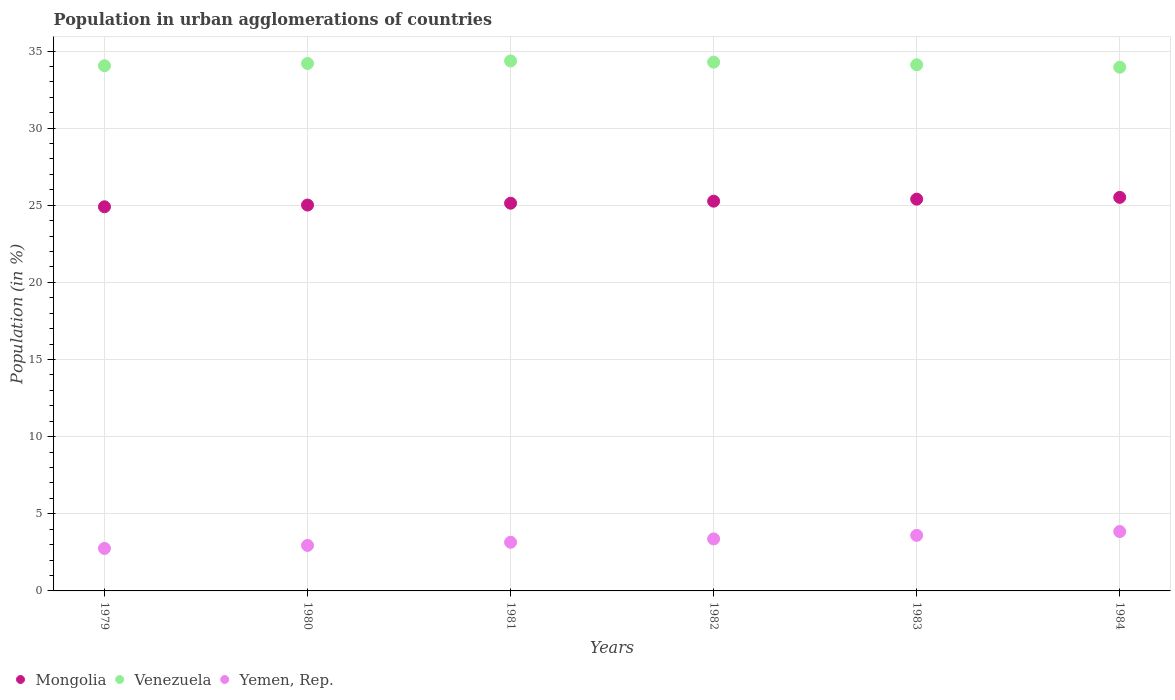What is the percentage of population in urban agglomerations in Venezuela in 1981?
Your answer should be very brief. 34.36. Across all years, what is the maximum percentage of population in urban agglomerations in Venezuela?
Offer a terse response. 34.36. Across all years, what is the minimum percentage of population in urban agglomerations in Mongolia?
Your response must be concise. 24.9. In which year was the percentage of population in urban agglomerations in Mongolia minimum?
Offer a very short reply. 1979. What is the total percentage of population in urban agglomerations in Venezuela in the graph?
Offer a very short reply. 204.93. What is the difference between the percentage of population in urban agglomerations in Mongolia in 1981 and that in 1984?
Ensure brevity in your answer.  -0.38. What is the difference between the percentage of population in urban agglomerations in Venezuela in 1981 and the percentage of population in urban agglomerations in Yemen, Rep. in 1982?
Offer a terse response. 30.99. What is the average percentage of population in urban agglomerations in Mongolia per year?
Keep it short and to the point. 25.2. In the year 1984, what is the difference between the percentage of population in urban agglomerations in Yemen, Rep. and percentage of population in urban agglomerations in Mongolia?
Provide a succinct answer. -21.66. In how many years, is the percentage of population in urban agglomerations in Yemen, Rep. greater than 16 %?
Give a very brief answer. 0. What is the ratio of the percentage of population in urban agglomerations in Venezuela in 1979 to that in 1981?
Your answer should be very brief. 0.99. Is the percentage of population in urban agglomerations in Mongolia in 1981 less than that in 1984?
Provide a short and direct response. Yes. Is the difference between the percentage of population in urban agglomerations in Yemen, Rep. in 1982 and 1984 greater than the difference between the percentage of population in urban agglomerations in Mongolia in 1982 and 1984?
Provide a short and direct response. No. What is the difference between the highest and the second highest percentage of population in urban agglomerations in Venezuela?
Give a very brief answer. 0.08. What is the difference between the highest and the lowest percentage of population in urban agglomerations in Venezuela?
Ensure brevity in your answer.  0.41. In how many years, is the percentage of population in urban agglomerations in Venezuela greater than the average percentage of population in urban agglomerations in Venezuela taken over all years?
Ensure brevity in your answer.  3. Is the sum of the percentage of population in urban agglomerations in Mongolia in 1982 and 1984 greater than the maximum percentage of population in urban agglomerations in Venezuela across all years?
Keep it short and to the point. Yes. Is it the case that in every year, the sum of the percentage of population in urban agglomerations in Mongolia and percentage of population in urban agglomerations in Yemen, Rep.  is greater than the percentage of population in urban agglomerations in Venezuela?
Your answer should be compact. No. Is the percentage of population in urban agglomerations in Venezuela strictly less than the percentage of population in urban agglomerations in Yemen, Rep. over the years?
Provide a short and direct response. No. How many dotlines are there?
Your response must be concise. 3. Where does the legend appear in the graph?
Give a very brief answer. Bottom left. How many legend labels are there?
Make the answer very short. 3. How are the legend labels stacked?
Ensure brevity in your answer.  Horizontal. What is the title of the graph?
Your response must be concise. Population in urban agglomerations of countries. What is the label or title of the Y-axis?
Your answer should be very brief. Population (in %). What is the Population (in %) in Mongolia in 1979?
Your response must be concise. 24.9. What is the Population (in %) of Venezuela in 1979?
Your answer should be very brief. 34.05. What is the Population (in %) of Yemen, Rep. in 1979?
Offer a very short reply. 2.76. What is the Population (in %) in Mongolia in 1980?
Your answer should be very brief. 25.01. What is the Population (in %) of Venezuela in 1980?
Provide a short and direct response. 34.19. What is the Population (in %) of Yemen, Rep. in 1980?
Your answer should be very brief. 2.95. What is the Population (in %) in Mongolia in 1981?
Provide a short and direct response. 25.13. What is the Population (in %) of Venezuela in 1981?
Provide a short and direct response. 34.36. What is the Population (in %) in Yemen, Rep. in 1981?
Your response must be concise. 3.15. What is the Population (in %) in Mongolia in 1982?
Your answer should be very brief. 25.27. What is the Population (in %) in Venezuela in 1982?
Provide a succinct answer. 34.28. What is the Population (in %) in Yemen, Rep. in 1982?
Offer a terse response. 3.37. What is the Population (in %) of Mongolia in 1983?
Your answer should be very brief. 25.4. What is the Population (in %) in Venezuela in 1983?
Offer a terse response. 34.11. What is the Population (in %) of Yemen, Rep. in 1983?
Provide a succinct answer. 3.6. What is the Population (in %) of Mongolia in 1984?
Provide a succinct answer. 25.51. What is the Population (in %) of Venezuela in 1984?
Give a very brief answer. 33.95. What is the Population (in %) of Yemen, Rep. in 1984?
Provide a short and direct response. 3.85. Across all years, what is the maximum Population (in %) in Mongolia?
Provide a succinct answer. 25.51. Across all years, what is the maximum Population (in %) in Venezuela?
Give a very brief answer. 34.36. Across all years, what is the maximum Population (in %) in Yemen, Rep.?
Offer a very short reply. 3.85. Across all years, what is the minimum Population (in %) in Mongolia?
Ensure brevity in your answer.  24.9. Across all years, what is the minimum Population (in %) in Venezuela?
Keep it short and to the point. 33.95. Across all years, what is the minimum Population (in %) in Yemen, Rep.?
Your answer should be compact. 2.76. What is the total Population (in %) in Mongolia in the graph?
Your response must be concise. 151.22. What is the total Population (in %) of Venezuela in the graph?
Offer a very short reply. 204.93. What is the total Population (in %) of Yemen, Rep. in the graph?
Provide a succinct answer. 19.68. What is the difference between the Population (in %) of Mongolia in 1979 and that in 1980?
Your answer should be very brief. -0.11. What is the difference between the Population (in %) in Venezuela in 1979 and that in 1980?
Keep it short and to the point. -0.15. What is the difference between the Population (in %) in Yemen, Rep. in 1979 and that in 1980?
Ensure brevity in your answer.  -0.19. What is the difference between the Population (in %) in Mongolia in 1979 and that in 1981?
Ensure brevity in your answer.  -0.23. What is the difference between the Population (in %) of Venezuela in 1979 and that in 1981?
Ensure brevity in your answer.  -0.31. What is the difference between the Population (in %) in Yemen, Rep. in 1979 and that in 1981?
Your answer should be compact. -0.4. What is the difference between the Population (in %) of Mongolia in 1979 and that in 1982?
Your response must be concise. -0.36. What is the difference between the Population (in %) of Venezuela in 1979 and that in 1982?
Give a very brief answer. -0.23. What is the difference between the Population (in %) in Yemen, Rep. in 1979 and that in 1982?
Offer a terse response. -0.62. What is the difference between the Population (in %) of Mongolia in 1979 and that in 1983?
Provide a succinct answer. -0.49. What is the difference between the Population (in %) of Venezuela in 1979 and that in 1983?
Provide a short and direct response. -0.06. What is the difference between the Population (in %) of Yemen, Rep. in 1979 and that in 1983?
Your response must be concise. -0.85. What is the difference between the Population (in %) in Mongolia in 1979 and that in 1984?
Give a very brief answer. -0.61. What is the difference between the Population (in %) of Venezuela in 1979 and that in 1984?
Ensure brevity in your answer.  0.1. What is the difference between the Population (in %) of Yemen, Rep. in 1979 and that in 1984?
Give a very brief answer. -1.09. What is the difference between the Population (in %) of Mongolia in 1980 and that in 1981?
Offer a terse response. -0.12. What is the difference between the Population (in %) in Venezuela in 1980 and that in 1981?
Your answer should be compact. -0.16. What is the difference between the Population (in %) of Yemen, Rep. in 1980 and that in 1981?
Your response must be concise. -0.2. What is the difference between the Population (in %) of Mongolia in 1980 and that in 1982?
Offer a terse response. -0.25. What is the difference between the Population (in %) in Venezuela in 1980 and that in 1982?
Give a very brief answer. -0.09. What is the difference between the Population (in %) in Yemen, Rep. in 1980 and that in 1982?
Ensure brevity in your answer.  -0.42. What is the difference between the Population (in %) of Mongolia in 1980 and that in 1983?
Ensure brevity in your answer.  -0.38. What is the difference between the Population (in %) in Venezuela in 1980 and that in 1983?
Keep it short and to the point. 0.09. What is the difference between the Population (in %) in Yemen, Rep. in 1980 and that in 1983?
Your answer should be compact. -0.65. What is the difference between the Population (in %) of Mongolia in 1980 and that in 1984?
Your answer should be very brief. -0.5. What is the difference between the Population (in %) of Venezuela in 1980 and that in 1984?
Give a very brief answer. 0.24. What is the difference between the Population (in %) of Yemen, Rep. in 1980 and that in 1984?
Ensure brevity in your answer.  -0.9. What is the difference between the Population (in %) in Mongolia in 1981 and that in 1982?
Your answer should be very brief. -0.13. What is the difference between the Population (in %) in Venezuela in 1981 and that in 1982?
Provide a short and direct response. 0.08. What is the difference between the Population (in %) of Yemen, Rep. in 1981 and that in 1982?
Your answer should be very brief. -0.22. What is the difference between the Population (in %) of Mongolia in 1981 and that in 1983?
Offer a terse response. -0.26. What is the difference between the Population (in %) in Venezuela in 1981 and that in 1983?
Offer a very short reply. 0.25. What is the difference between the Population (in %) in Yemen, Rep. in 1981 and that in 1983?
Make the answer very short. -0.45. What is the difference between the Population (in %) in Mongolia in 1981 and that in 1984?
Give a very brief answer. -0.38. What is the difference between the Population (in %) in Venezuela in 1981 and that in 1984?
Ensure brevity in your answer.  0.41. What is the difference between the Population (in %) of Yemen, Rep. in 1981 and that in 1984?
Keep it short and to the point. -0.69. What is the difference between the Population (in %) of Mongolia in 1982 and that in 1983?
Offer a very short reply. -0.13. What is the difference between the Population (in %) in Venezuela in 1982 and that in 1983?
Your response must be concise. 0.17. What is the difference between the Population (in %) of Yemen, Rep. in 1982 and that in 1983?
Your answer should be compact. -0.23. What is the difference between the Population (in %) in Mongolia in 1982 and that in 1984?
Your answer should be compact. -0.25. What is the difference between the Population (in %) in Venezuela in 1982 and that in 1984?
Ensure brevity in your answer.  0.33. What is the difference between the Population (in %) in Yemen, Rep. in 1982 and that in 1984?
Provide a succinct answer. -0.48. What is the difference between the Population (in %) of Mongolia in 1983 and that in 1984?
Offer a very short reply. -0.12. What is the difference between the Population (in %) of Venezuela in 1983 and that in 1984?
Your response must be concise. 0.16. What is the difference between the Population (in %) of Yemen, Rep. in 1983 and that in 1984?
Give a very brief answer. -0.25. What is the difference between the Population (in %) in Mongolia in 1979 and the Population (in %) in Venezuela in 1980?
Provide a succinct answer. -9.29. What is the difference between the Population (in %) in Mongolia in 1979 and the Population (in %) in Yemen, Rep. in 1980?
Make the answer very short. 21.95. What is the difference between the Population (in %) in Venezuela in 1979 and the Population (in %) in Yemen, Rep. in 1980?
Ensure brevity in your answer.  31.1. What is the difference between the Population (in %) in Mongolia in 1979 and the Population (in %) in Venezuela in 1981?
Keep it short and to the point. -9.45. What is the difference between the Population (in %) of Mongolia in 1979 and the Population (in %) of Yemen, Rep. in 1981?
Your answer should be very brief. 21.75. What is the difference between the Population (in %) of Venezuela in 1979 and the Population (in %) of Yemen, Rep. in 1981?
Provide a succinct answer. 30.89. What is the difference between the Population (in %) in Mongolia in 1979 and the Population (in %) in Venezuela in 1982?
Provide a short and direct response. -9.38. What is the difference between the Population (in %) in Mongolia in 1979 and the Population (in %) in Yemen, Rep. in 1982?
Your answer should be very brief. 21.53. What is the difference between the Population (in %) in Venezuela in 1979 and the Population (in %) in Yemen, Rep. in 1982?
Keep it short and to the point. 30.67. What is the difference between the Population (in %) of Mongolia in 1979 and the Population (in %) of Venezuela in 1983?
Your answer should be very brief. -9.2. What is the difference between the Population (in %) of Mongolia in 1979 and the Population (in %) of Yemen, Rep. in 1983?
Offer a terse response. 21.3. What is the difference between the Population (in %) of Venezuela in 1979 and the Population (in %) of Yemen, Rep. in 1983?
Your response must be concise. 30.44. What is the difference between the Population (in %) in Mongolia in 1979 and the Population (in %) in Venezuela in 1984?
Your response must be concise. -9.05. What is the difference between the Population (in %) in Mongolia in 1979 and the Population (in %) in Yemen, Rep. in 1984?
Offer a very short reply. 21.05. What is the difference between the Population (in %) of Venezuela in 1979 and the Population (in %) of Yemen, Rep. in 1984?
Offer a very short reply. 30.2. What is the difference between the Population (in %) of Mongolia in 1980 and the Population (in %) of Venezuela in 1981?
Your answer should be very brief. -9.34. What is the difference between the Population (in %) of Mongolia in 1980 and the Population (in %) of Yemen, Rep. in 1981?
Give a very brief answer. 21.86. What is the difference between the Population (in %) in Venezuela in 1980 and the Population (in %) in Yemen, Rep. in 1981?
Provide a succinct answer. 31.04. What is the difference between the Population (in %) of Mongolia in 1980 and the Population (in %) of Venezuela in 1982?
Offer a terse response. -9.26. What is the difference between the Population (in %) in Mongolia in 1980 and the Population (in %) in Yemen, Rep. in 1982?
Make the answer very short. 21.64. What is the difference between the Population (in %) of Venezuela in 1980 and the Population (in %) of Yemen, Rep. in 1982?
Your answer should be very brief. 30.82. What is the difference between the Population (in %) in Mongolia in 1980 and the Population (in %) in Venezuela in 1983?
Offer a terse response. -9.09. What is the difference between the Population (in %) of Mongolia in 1980 and the Population (in %) of Yemen, Rep. in 1983?
Provide a short and direct response. 21.41. What is the difference between the Population (in %) of Venezuela in 1980 and the Population (in %) of Yemen, Rep. in 1983?
Make the answer very short. 30.59. What is the difference between the Population (in %) in Mongolia in 1980 and the Population (in %) in Venezuela in 1984?
Your answer should be very brief. -8.93. What is the difference between the Population (in %) in Mongolia in 1980 and the Population (in %) in Yemen, Rep. in 1984?
Make the answer very short. 21.17. What is the difference between the Population (in %) in Venezuela in 1980 and the Population (in %) in Yemen, Rep. in 1984?
Offer a very short reply. 30.34. What is the difference between the Population (in %) in Mongolia in 1981 and the Population (in %) in Venezuela in 1982?
Offer a very short reply. -9.15. What is the difference between the Population (in %) in Mongolia in 1981 and the Population (in %) in Yemen, Rep. in 1982?
Give a very brief answer. 21.76. What is the difference between the Population (in %) of Venezuela in 1981 and the Population (in %) of Yemen, Rep. in 1982?
Make the answer very short. 30.99. What is the difference between the Population (in %) in Mongolia in 1981 and the Population (in %) in Venezuela in 1983?
Offer a terse response. -8.97. What is the difference between the Population (in %) in Mongolia in 1981 and the Population (in %) in Yemen, Rep. in 1983?
Keep it short and to the point. 21.53. What is the difference between the Population (in %) in Venezuela in 1981 and the Population (in %) in Yemen, Rep. in 1983?
Your response must be concise. 30.75. What is the difference between the Population (in %) in Mongolia in 1981 and the Population (in %) in Venezuela in 1984?
Your answer should be compact. -8.82. What is the difference between the Population (in %) in Mongolia in 1981 and the Population (in %) in Yemen, Rep. in 1984?
Your answer should be very brief. 21.29. What is the difference between the Population (in %) of Venezuela in 1981 and the Population (in %) of Yemen, Rep. in 1984?
Offer a terse response. 30.51. What is the difference between the Population (in %) of Mongolia in 1982 and the Population (in %) of Venezuela in 1983?
Your answer should be compact. -8.84. What is the difference between the Population (in %) of Mongolia in 1982 and the Population (in %) of Yemen, Rep. in 1983?
Give a very brief answer. 21.66. What is the difference between the Population (in %) of Venezuela in 1982 and the Population (in %) of Yemen, Rep. in 1983?
Ensure brevity in your answer.  30.68. What is the difference between the Population (in %) in Mongolia in 1982 and the Population (in %) in Venezuela in 1984?
Your response must be concise. -8.68. What is the difference between the Population (in %) of Mongolia in 1982 and the Population (in %) of Yemen, Rep. in 1984?
Keep it short and to the point. 21.42. What is the difference between the Population (in %) of Venezuela in 1982 and the Population (in %) of Yemen, Rep. in 1984?
Keep it short and to the point. 30.43. What is the difference between the Population (in %) in Mongolia in 1983 and the Population (in %) in Venezuela in 1984?
Give a very brief answer. -8.55. What is the difference between the Population (in %) of Mongolia in 1983 and the Population (in %) of Yemen, Rep. in 1984?
Keep it short and to the point. 21.55. What is the difference between the Population (in %) of Venezuela in 1983 and the Population (in %) of Yemen, Rep. in 1984?
Make the answer very short. 30.26. What is the average Population (in %) of Mongolia per year?
Make the answer very short. 25.2. What is the average Population (in %) in Venezuela per year?
Keep it short and to the point. 34.15. What is the average Population (in %) of Yemen, Rep. per year?
Your answer should be compact. 3.28. In the year 1979, what is the difference between the Population (in %) of Mongolia and Population (in %) of Venezuela?
Ensure brevity in your answer.  -9.14. In the year 1979, what is the difference between the Population (in %) in Mongolia and Population (in %) in Yemen, Rep.?
Offer a very short reply. 22.15. In the year 1979, what is the difference between the Population (in %) in Venezuela and Population (in %) in Yemen, Rep.?
Keep it short and to the point. 31.29. In the year 1980, what is the difference between the Population (in %) of Mongolia and Population (in %) of Venezuela?
Your answer should be very brief. -9.18. In the year 1980, what is the difference between the Population (in %) of Mongolia and Population (in %) of Yemen, Rep.?
Your answer should be compact. 22.07. In the year 1980, what is the difference between the Population (in %) in Venezuela and Population (in %) in Yemen, Rep.?
Ensure brevity in your answer.  31.24. In the year 1981, what is the difference between the Population (in %) in Mongolia and Population (in %) in Venezuela?
Provide a short and direct response. -9.22. In the year 1981, what is the difference between the Population (in %) in Mongolia and Population (in %) in Yemen, Rep.?
Provide a succinct answer. 21.98. In the year 1981, what is the difference between the Population (in %) of Venezuela and Population (in %) of Yemen, Rep.?
Your answer should be compact. 31.2. In the year 1982, what is the difference between the Population (in %) of Mongolia and Population (in %) of Venezuela?
Ensure brevity in your answer.  -9.01. In the year 1982, what is the difference between the Population (in %) of Mongolia and Population (in %) of Yemen, Rep.?
Offer a terse response. 21.89. In the year 1982, what is the difference between the Population (in %) in Venezuela and Population (in %) in Yemen, Rep.?
Ensure brevity in your answer.  30.91. In the year 1983, what is the difference between the Population (in %) in Mongolia and Population (in %) in Venezuela?
Provide a short and direct response. -8.71. In the year 1983, what is the difference between the Population (in %) of Mongolia and Population (in %) of Yemen, Rep.?
Ensure brevity in your answer.  21.79. In the year 1983, what is the difference between the Population (in %) of Venezuela and Population (in %) of Yemen, Rep.?
Ensure brevity in your answer.  30.5. In the year 1984, what is the difference between the Population (in %) of Mongolia and Population (in %) of Venezuela?
Ensure brevity in your answer.  -8.44. In the year 1984, what is the difference between the Population (in %) in Mongolia and Population (in %) in Yemen, Rep.?
Ensure brevity in your answer.  21.66. In the year 1984, what is the difference between the Population (in %) of Venezuela and Population (in %) of Yemen, Rep.?
Offer a terse response. 30.1. What is the ratio of the Population (in %) in Mongolia in 1979 to that in 1980?
Give a very brief answer. 1. What is the ratio of the Population (in %) of Yemen, Rep. in 1979 to that in 1980?
Your answer should be compact. 0.93. What is the ratio of the Population (in %) in Yemen, Rep. in 1979 to that in 1981?
Provide a short and direct response. 0.87. What is the ratio of the Population (in %) of Mongolia in 1979 to that in 1982?
Give a very brief answer. 0.99. What is the ratio of the Population (in %) of Yemen, Rep. in 1979 to that in 1982?
Your response must be concise. 0.82. What is the ratio of the Population (in %) of Mongolia in 1979 to that in 1983?
Your answer should be very brief. 0.98. What is the ratio of the Population (in %) in Yemen, Rep. in 1979 to that in 1983?
Keep it short and to the point. 0.77. What is the ratio of the Population (in %) of Mongolia in 1979 to that in 1984?
Offer a very short reply. 0.98. What is the ratio of the Population (in %) in Yemen, Rep. in 1979 to that in 1984?
Offer a very short reply. 0.72. What is the ratio of the Population (in %) of Yemen, Rep. in 1980 to that in 1981?
Make the answer very short. 0.94. What is the ratio of the Population (in %) in Yemen, Rep. in 1980 to that in 1982?
Ensure brevity in your answer.  0.87. What is the ratio of the Population (in %) in Mongolia in 1980 to that in 1983?
Give a very brief answer. 0.98. What is the ratio of the Population (in %) in Venezuela in 1980 to that in 1983?
Make the answer very short. 1. What is the ratio of the Population (in %) of Yemen, Rep. in 1980 to that in 1983?
Offer a terse response. 0.82. What is the ratio of the Population (in %) of Mongolia in 1980 to that in 1984?
Ensure brevity in your answer.  0.98. What is the ratio of the Population (in %) in Yemen, Rep. in 1980 to that in 1984?
Offer a very short reply. 0.77. What is the ratio of the Population (in %) of Yemen, Rep. in 1981 to that in 1982?
Provide a short and direct response. 0.94. What is the ratio of the Population (in %) of Venezuela in 1981 to that in 1983?
Ensure brevity in your answer.  1.01. What is the ratio of the Population (in %) in Yemen, Rep. in 1981 to that in 1983?
Ensure brevity in your answer.  0.88. What is the ratio of the Population (in %) in Mongolia in 1981 to that in 1984?
Your answer should be compact. 0.99. What is the ratio of the Population (in %) of Yemen, Rep. in 1981 to that in 1984?
Your answer should be compact. 0.82. What is the ratio of the Population (in %) of Mongolia in 1982 to that in 1983?
Offer a terse response. 0.99. What is the ratio of the Population (in %) in Venezuela in 1982 to that in 1983?
Ensure brevity in your answer.  1.01. What is the ratio of the Population (in %) of Yemen, Rep. in 1982 to that in 1983?
Your answer should be compact. 0.94. What is the ratio of the Population (in %) in Mongolia in 1982 to that in 1984?
Make the answer very short. 0.99. What is the ratio of the Population (in %) of Venezuela in 1982 to that in 1984?
Your answer should be very brief. 1.01. What is the ratio of the Population (in %) in Yemen, Rep. in 1982 to that in 1984?
Your response must be concise. 0.88. What is the ratio of the Population (in %) in Mongolia in 1983 to that in 1984?
Make the answer very short. 1. What is the ratio of the Population (in %) of Yemen, Rep. in 1983 to that in 1984?
Make the answer very short. 0.94. What is the difference between the highest and the second highest Population (in %) of Mongolia?
Ensure brevity in your answer.  0.12. What is the difference between the highest and the second highest Population (in %) of Venezuela?
Ensure brevity in your answer.  0.08. What is the difference between the highest and the second highest Population (in %) of Yemen, Rep.?
Offer a terse response. 0.25. What is the difference between the highest and the lowest Population (in %) in Mongolia?
Your response must be concise. 0.61. What is the difference between the highest and the lowest Population (in %) in Venezuela?
Ensure brevity in your answer.  0.41. What is the difference between the highest and the lowest Population (in %) in Yemen, Rep.?
Make the answer very short. 1.09. 